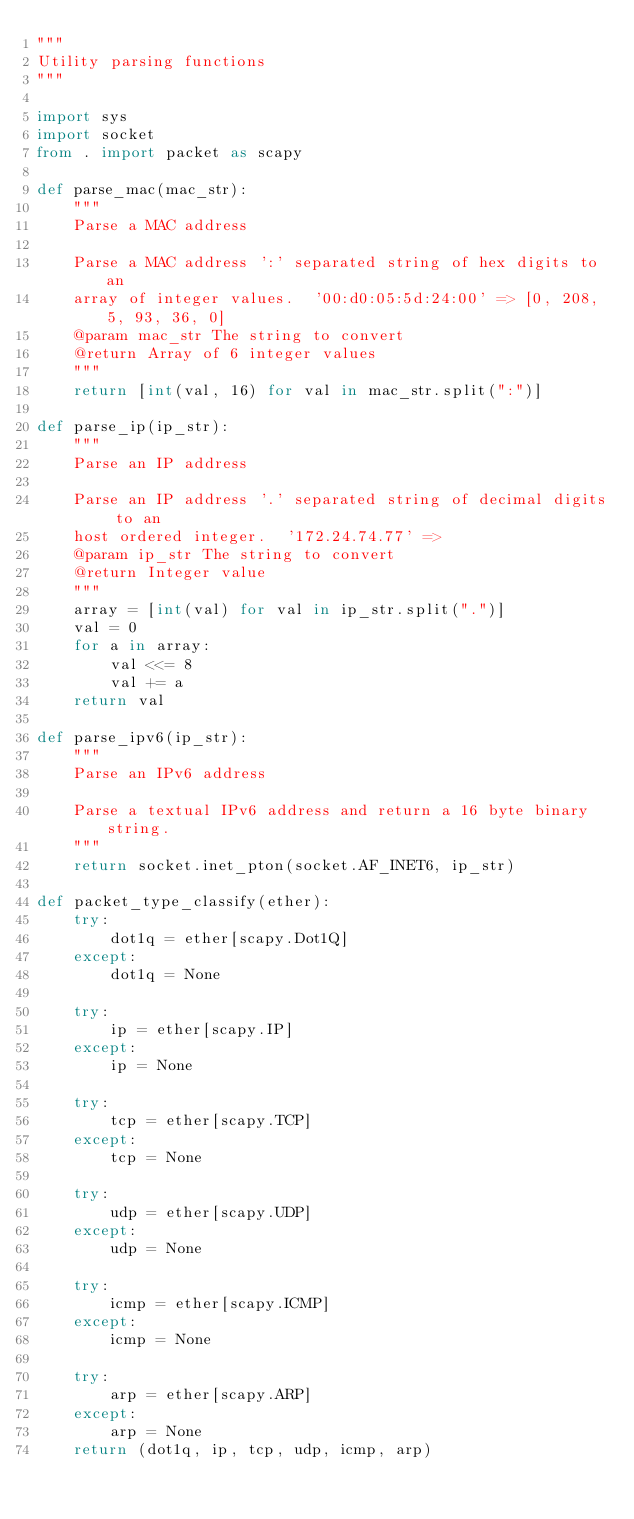Convert code to text. <code><loc_0><loc_0><loc_500><loc_500><_Python_>"""
Utility parsing functions
"""

import sys
import socket
from . import packet as scapy

def parse_mac(mac_str):
    """
    Parse a MAC address

    Parse a MAC address ':' separated string of hex digits to an
    array of integer values.  '00:d0:05:5d:24:00' => [0, 208, 5, 93, 36, 0]
    @param mac_str The string to convert
    @return Array of 6 integer values
    """
    return [int(val, 16) for val in mac_str.split(":")]

def parse_ip(ip_str):
    """
    Parse an IP address

    Parse an IP address '.' separated string of decimal digits to an
    host ordered integer.  '172.24.74.77' => 
    @param ip_str The string to convert
    @return Integer value
    """
    array = [int(val) for val in ip_str.split(".")]
    val = 0
    for a in array:
        val <<= 8
        val += a
    return val

def parse_ipv6(ip_str):
    """
    Parse an IPv6 address

    Parse a textual IPv6 address and return a 16 byte binary string.
    """
    return socket.inet_pton(socket.AF_INET6, ip_str)

def packet_type_classify(ether):
    try:
        dot1q = ether[scapy.Dot1Q]
    except:
        dot1q = None

    try:
        ip = ether[scapy.IP]
    except:
        ip = None

    try:
        tcp = ether[scapy.TCP]
    except:
        tcp = None

    try:
        udp = ether[scapy.UDP]
    except:
        udp = None

    try:
        icmp = ether[scapy.ICMP]
    except:
        icmp = None

    try:
        arp = ether[scapy.ARP]
    except:
        arp = None
    return (dot1q, ip, tcp, udp, icmp, arp)
</code> 